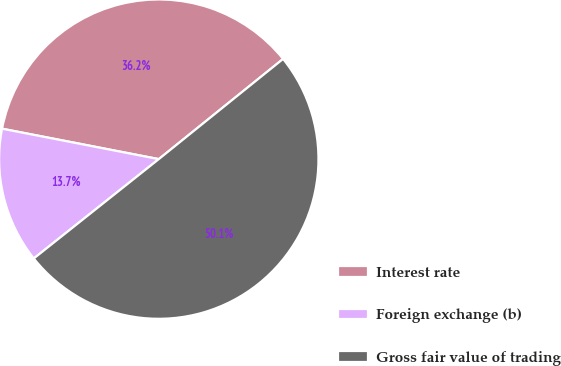Convert chart to OTSL. <chart><loc_0><loc_0><loc_500><loc_500><pie_chart><fcel>Interest rate<fcel>Foreign exchange (b)<fcel>Gross fair value of trading<nl><fcel>36.15%<fcel>13.74%<fcel>50.11%<nl></chart> 